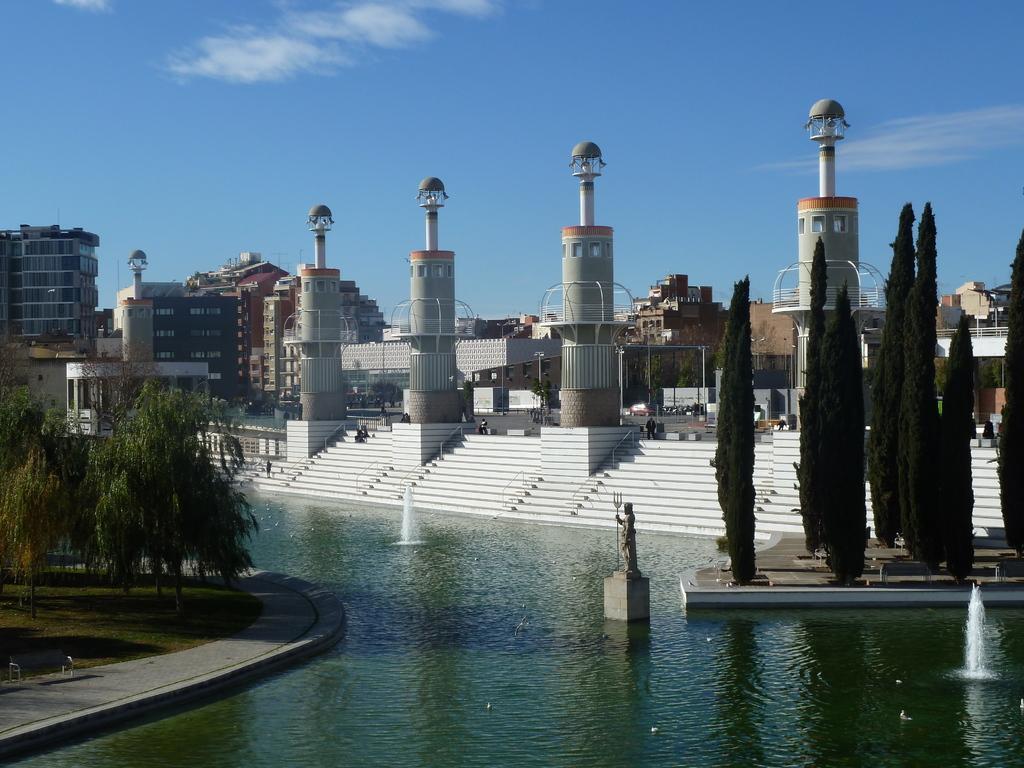Describe this image in one or two sentences. At the bottom of the image there is water. There are fountains in the water. And also there is a statue on the pedestal. And in the image there are trees. Behind the trees there are steps. On the steps there are pillars. Behind them there are poles and also there are buildings. At the top of the image there is sky. 